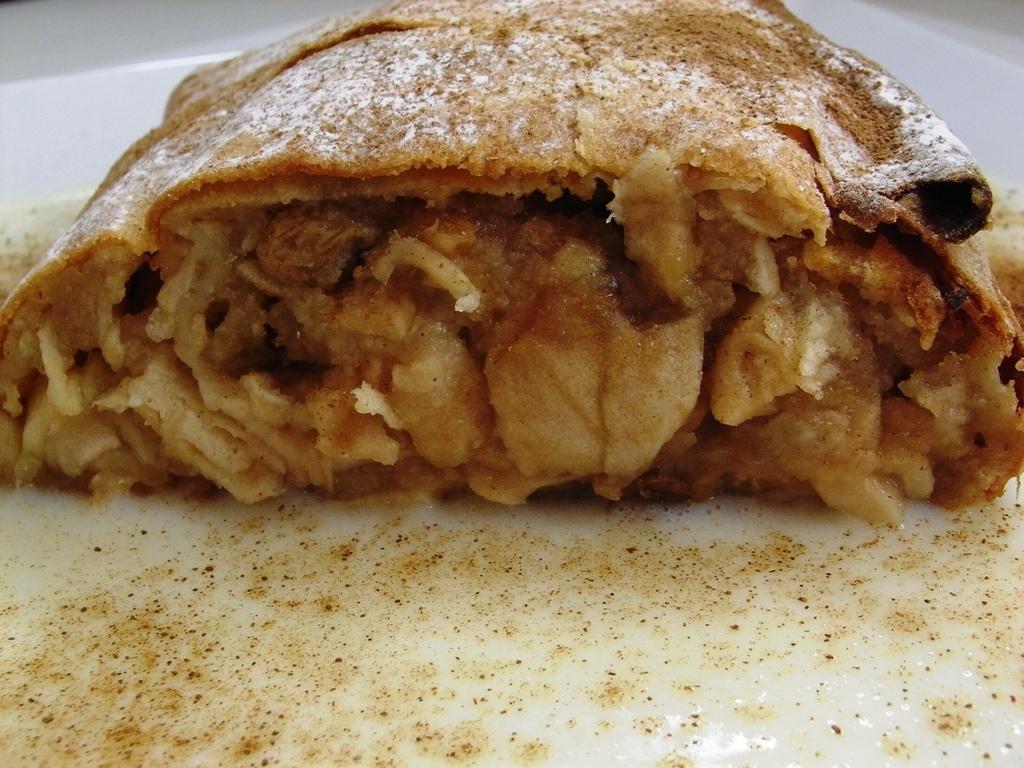Describe this image in one or two sentences. In this picture, we see a white plate containing an edible. In the background, it is white in color. 